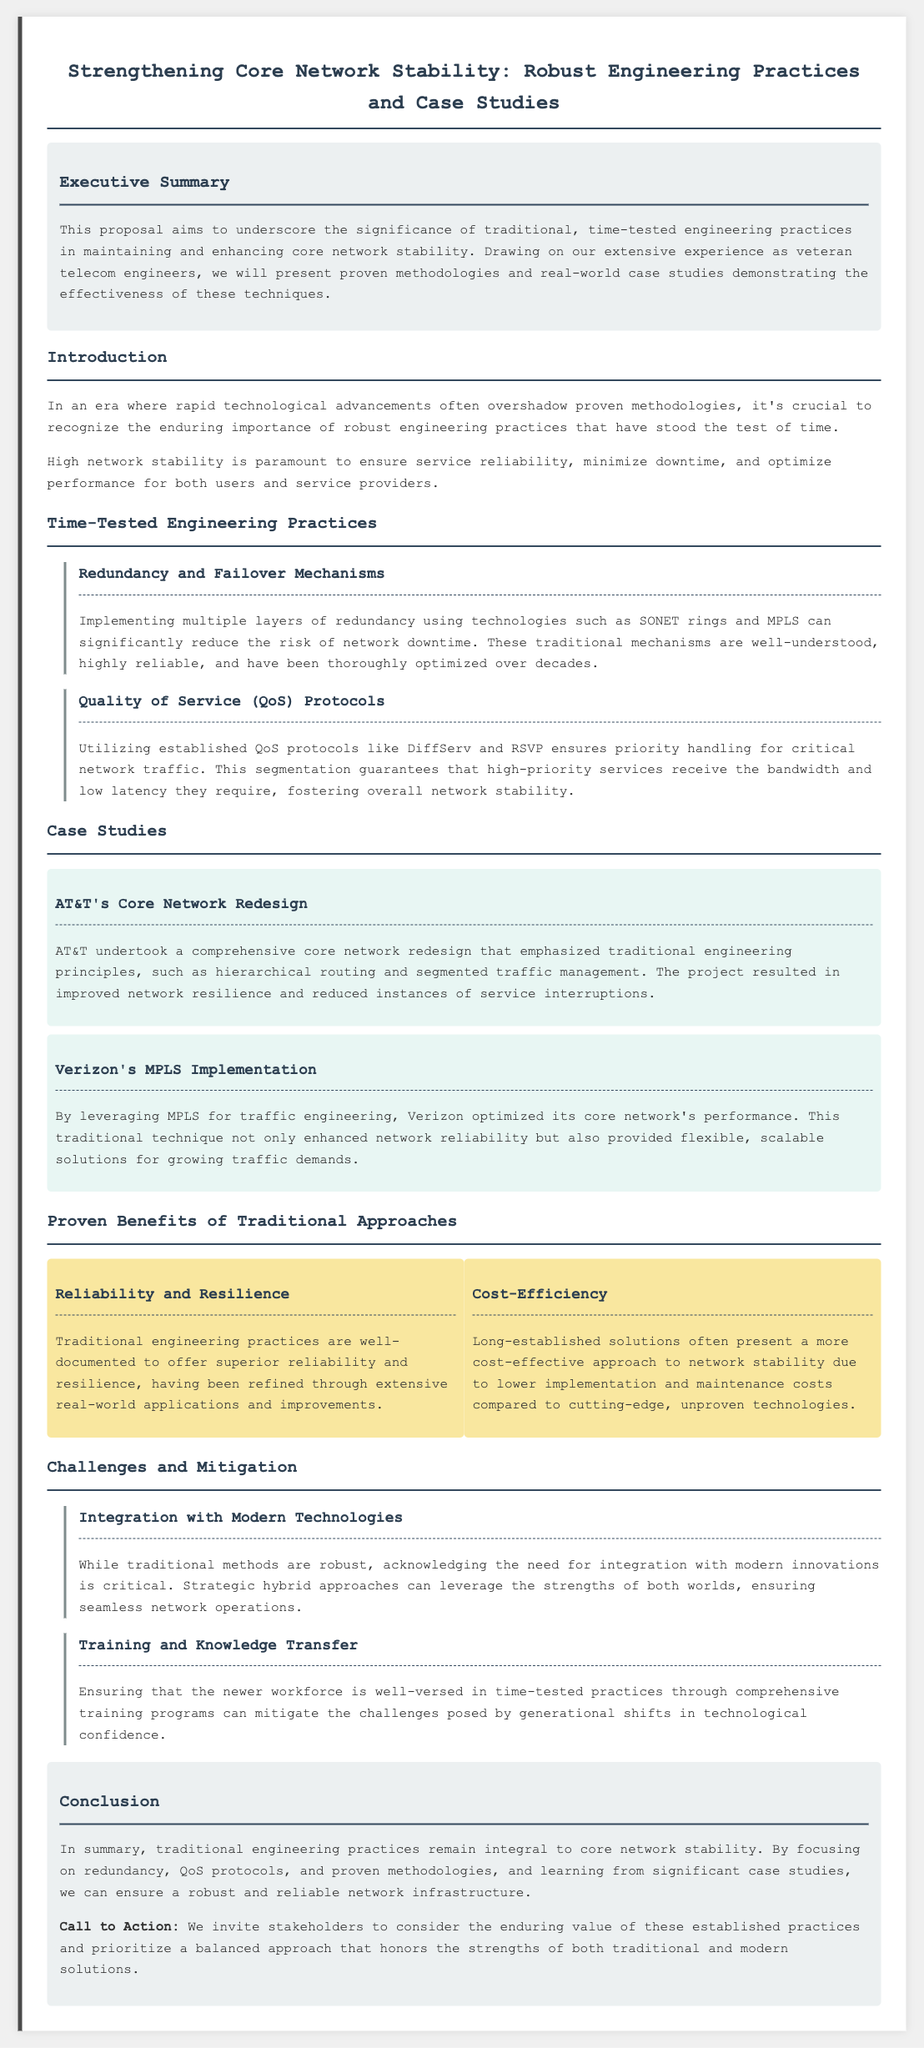What is the title of the proposal? The title indicates the main focus of the document, which is about strengthening core network stability through engineering practices.
Answer: Strengthening Core Network Stability: Robust Engineering Practices and Case Studies What are the two main engineering practices discussed in the proposal? These practices are specifically highlighted in the section about time-tested engineering practices as essential methods to ensure network stability.
Answer: Redundancy and Failover Mechanisms, Quality of Service (QoS) Protocols Which company undertook a core network redesign? The case studies in the document provide examples of companies that successfully applied traditional engineering principles.
Answer: AT&T What is one proven benefit of traditional approaches mentioned? The proposal lists benefits that emphasize the value of established practices for network stability.
Answer: Reliability and Resilience What challenge relates to the new workforce? The document outlines certain challenges that need to be addressed to maintain core network stability, specifically regarding the generation gap in knowledge.
Answer: Training and Knowledge Transfer How does the document describe the handling of critical network traffic? This information pertains to the established protocols used to ensure that important services are prioritized effectively within the network.
Answer: QoS protocols like DiffServ and RSVP What do the case studies demonstrate? The document highlights case studies to showcase practical applications and results from implementing traditional practices in real-world scenarios.
Answer: Effectiveness of traditional engineering principles What call to action is included in the conclusion? This part of the document encourages stakeholders to consider the mentioned practices and their value in network infrastructure.
Answer: Prioritize a balanced approach that honors the strengths of both traditional and modern solutions 